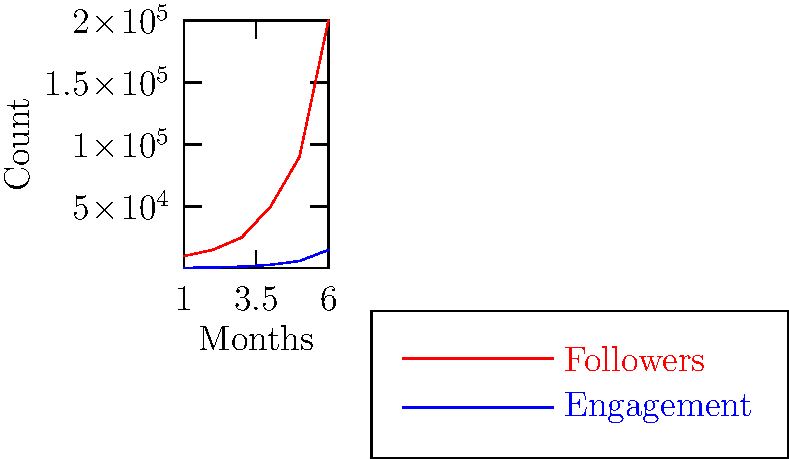As an emerging hip-hop artist, you're analyzing your social media growth over the past 6 months. The red line represents your follower count, while the blue line shows your engagement (likes, comments, shares). If the trend continues, what would be the approximate ratio of engagement to followers at the end of month 8? To solve this question, we need to follow these steps:

1. Observe the growth pattern:
   - Both followers and engagement show exponential growth.
   - The ratio between engagement and followers seems to be relatively consistent.

2. Estimate the values for month 8:
   - Followers (red line):
     Month 6: 200,000
     Month 8 (estimated): ~800,000 (doubling twice)
   - Engagement (blue line):
     Month 6: 15,000
     Month 8 (estimated): ~60,000 (doubling twice)

3. Calculate the ratio:
   $\frac{\text{Engagement}}{\text{Followers}} = \frac{60,000}{800,000} = \frac{3}{40} = 0.075$

4. Convert to a percentage:
   $0.075 \times 100\% = 7.5\%$

Therefore, if the trend continues, the engagement-to-followers ratio at the end of month 8 would be approximately 7.5%.
Answer: 7.5% 